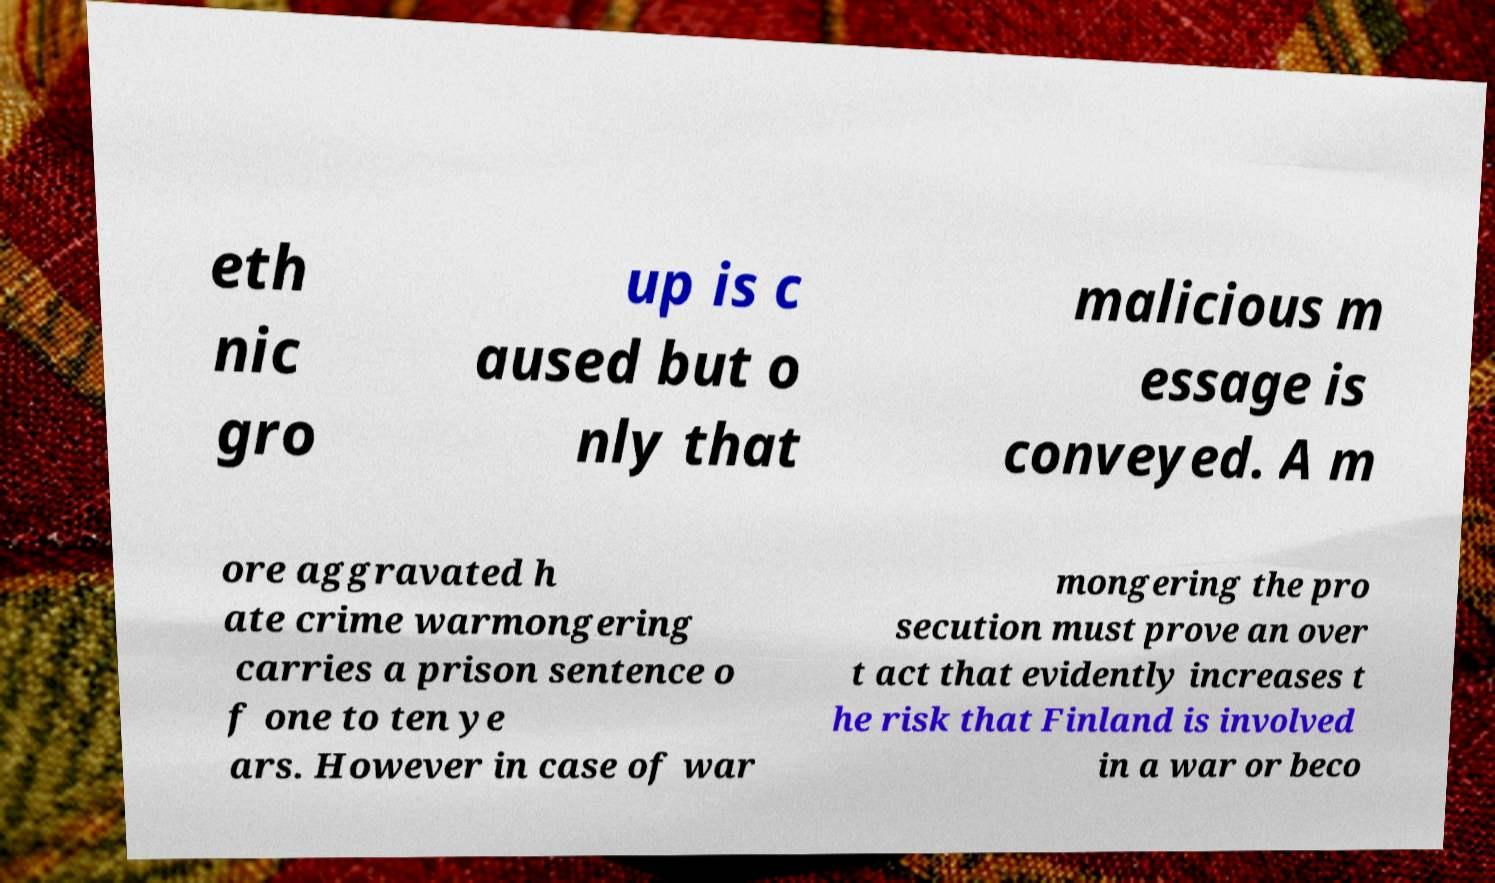Can you accurately transcribe the text from the provided image for me? eth nic gro up is c aused but o nly that malicious m essage is conveyed. A m ore aggravated h ate crime warmongering carries a prison sentence o f one to ten ye ars. However in case of war mongering the pro secution must prove an over t act that evidently increases t he risk that Finland is involved in a war or beco 